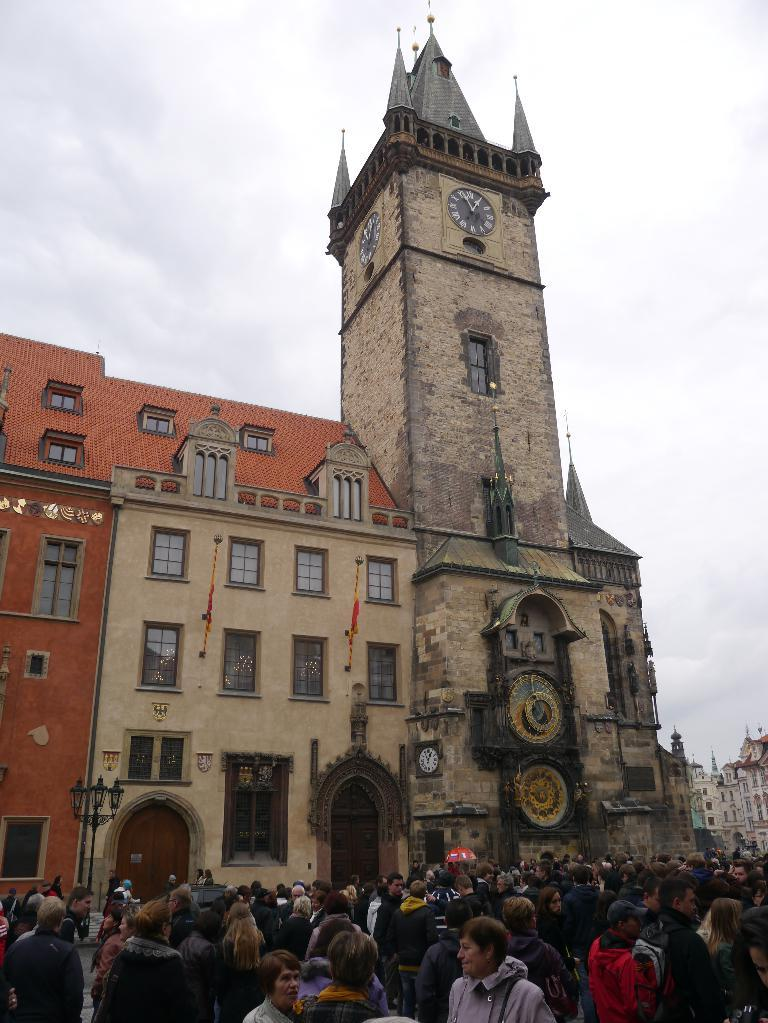What can be seen in the image regarding people? There are persons wearing clothes in the image. What structure is located in the middle of the image? There is a building in the middle of the image. What is visible at the top of the image? The sky is visible at the top of the image. Can you hear a whistle in the image? There is no mention of a whistle in the image, so it cannot be heard. What type of bushes are present in the image? There is no mention of bushes in the image, so it cannot be determined if any are present. 